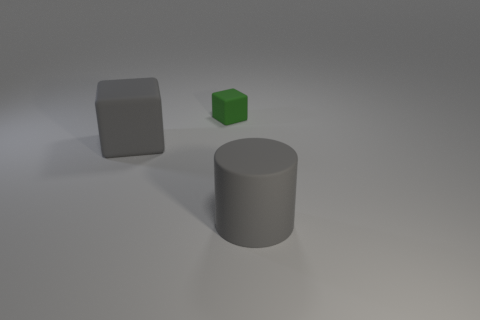Add 1 large blocks. How many objects exist? 4 Subtract all blocks. How many objects are left? 1 Subtract all brown cylinders. Subtract all purple blocks. How many cylinders are left? 1 Subtract all green balls. How many cyan cubes are left? 0 Subtract all tiny gray metallic things. Subtract all gray cubes. How many objects are left? 2 Add 3 small cubes. How many small cubes are left? 4 Add 3 large red matte spheres. How many large red matte spheres exist? 3 Subtract 0 brown cubes. How many objects are left? 3 